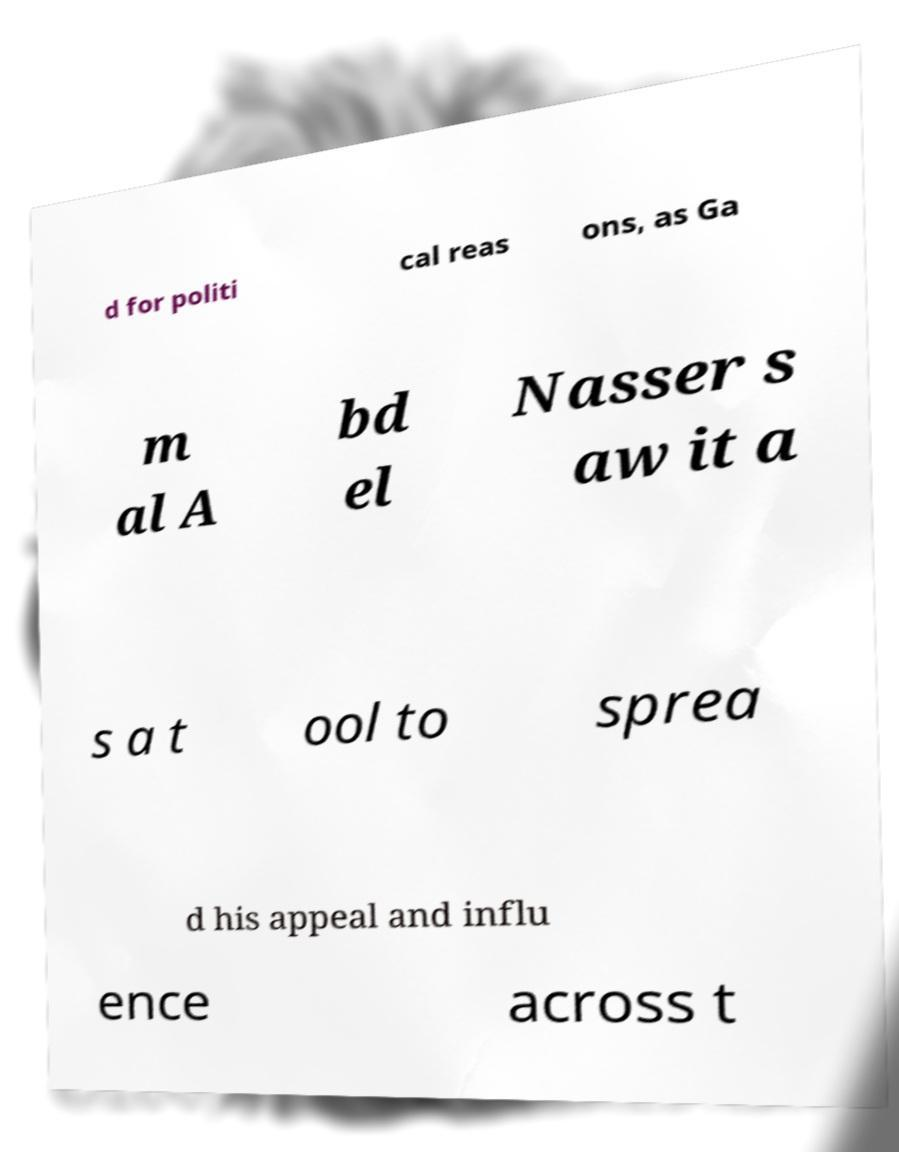There's text embedded in this image that I need extracted. Can you transcribe it verbatim? d for politi cal reas ons, as Ga m al A bd el Nasser s aw it a s a t ool to sprea d his appeal and influ ence across t 